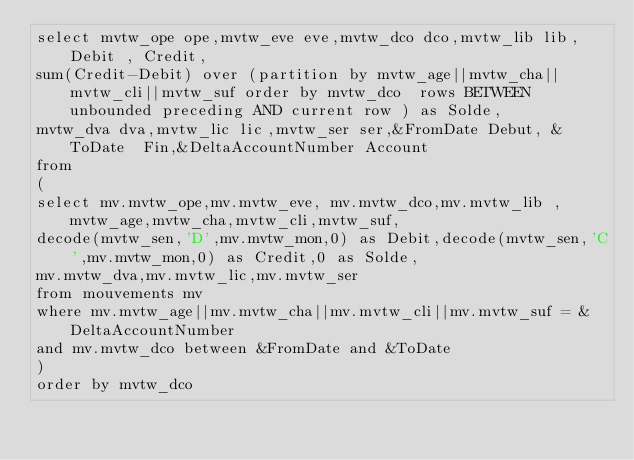Convert code to text. <code><loc_0><loc_0><loc_500><loc_500><_SQL_>select mvtw_ope ope,mvtw_eve eve,mvtw_dco dco,mvtw_lib lib, Debit , Credit,
sum(Credit-Debit) over (partition by mvtw_age||mvtw_cha||mvtw_cli||mvtw_suf order by mvtw_dco  rows BETWEEN unbounded preceding AND current row ) as Solde,
mvtw_dva dva,mvtw_lic lic,mvtw_ser ser,&FromDate Debut, &ToDate  Fin,&DeltaAccountNumber Account
from 
(
select mv.mvtw_ope,mv.mvtw_eve, mv.mvtw_dco,mv.mvtw_lib ,mvtw_age,mvtw_cha,mvtw_cli,mvtw_suf,
decode(mvtw_sen,'D',mv.mvtw_mon,0) as Debit,decode(mvtw_sen,'C',mv.mvtw_mon,0) as Credit,0 as Solde,
mv.mvtw_dva,mv.mvtw_lic,mv.mvtw_ser
from mouvements mv
where mv.mvtw_age||mv.mvtw_cha||mv.mvtw_cli||mv.mvtw_suf = &DeltaAccountNumber
and mv.mvtw_dco between &FromDate and &ToDate
)
order by mvtw_dco




</code> 